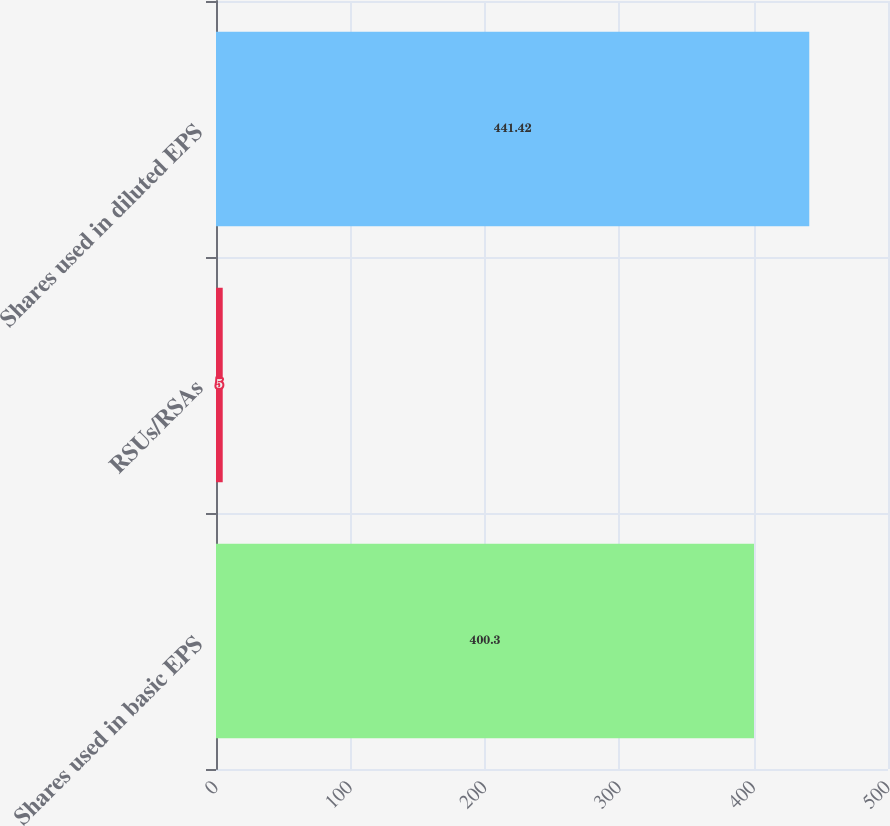<chart> <loc_0><loc_0><loc_500><loc_500><bar_chart><fcel>Shares used in basic EPS<fcel>RSUs/RSAs<fcel>Shares used in diluted EPS<nl><fcel>400.3<fcel>5<fcel>441.42<nl></chart> 